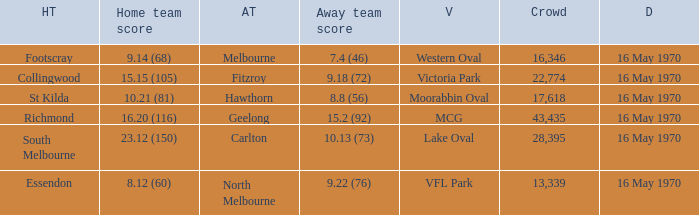I'm looking to parse the entire table for insights. Could you assist me with that? {'header': ['HT', 'Home team score', 'AT', 'Away team score', 'V', 'Crowd', 'D'], 'rows': [['Footscray', '9.14 (68)', 'Melbourne', '7.4 (46)', 'Western Oval', '16,346', '16 May 1970'], ['Collingwood', '15.15 (105)', 'Fitzroy', '9.18 (72)', 'Victoria Park', '22,774', '16 May 1970'], ['St Kilda', '10.21 (81)', 'Hawthorn', '8.8 (56)', 'Moorabbin Oval', '17,618', '16 May 1970'], ['Richmond', '16.20 (116)', 'Geelong', '15.2 (92)', 'MCG', '43,435', '16 May 1970'], ['South Melbourne', '23.12 (150)', 'Carlton', '10.13 (73)', 'Lake Oval', '28,395', '16 May 1970'], ['Essendon', '8.12 (60)', 'North Melbourne', '9.22 (76)', 'VFL Park', '13,339', '16 May 1970']]} What away team scored 9.18 (72)? Fitzroy. 